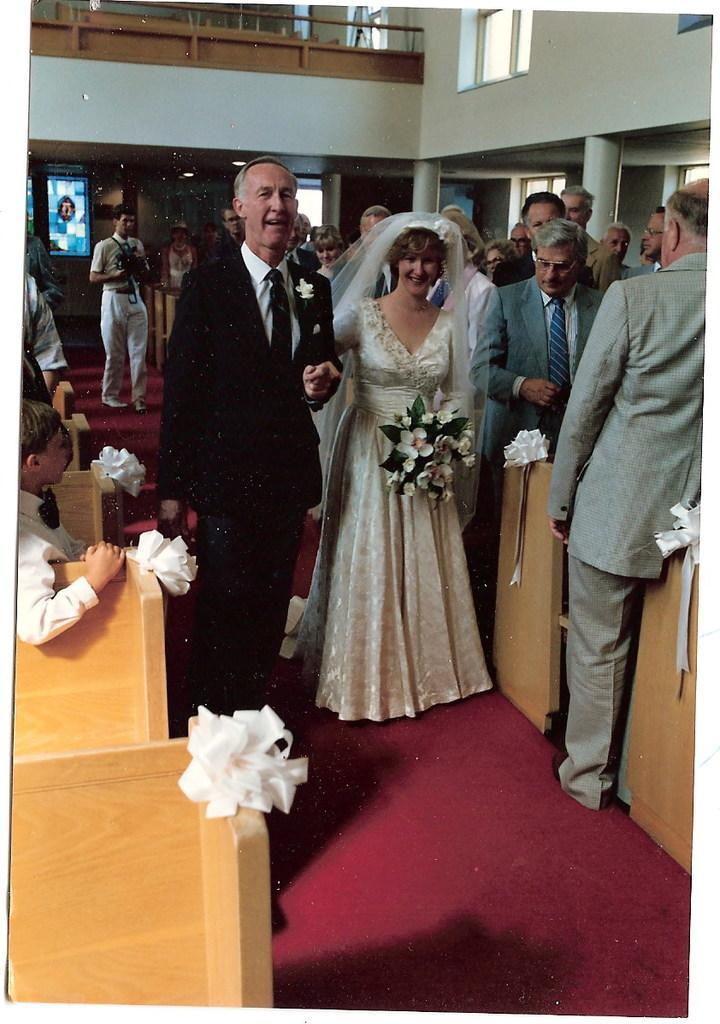Please provide a concise description of this image. There is a man in suit holding a hand of a woman who is in white color dress and is holding flower bookey with other hand, on the floor which is covered with red color carpet. On the both this carpet, there are chairs arranged. On the left side, there is a person sitting on a chair. On the right side, there are persons standing. In the background, there are persons standing, there are pillars, a window, balcony and white wall. 